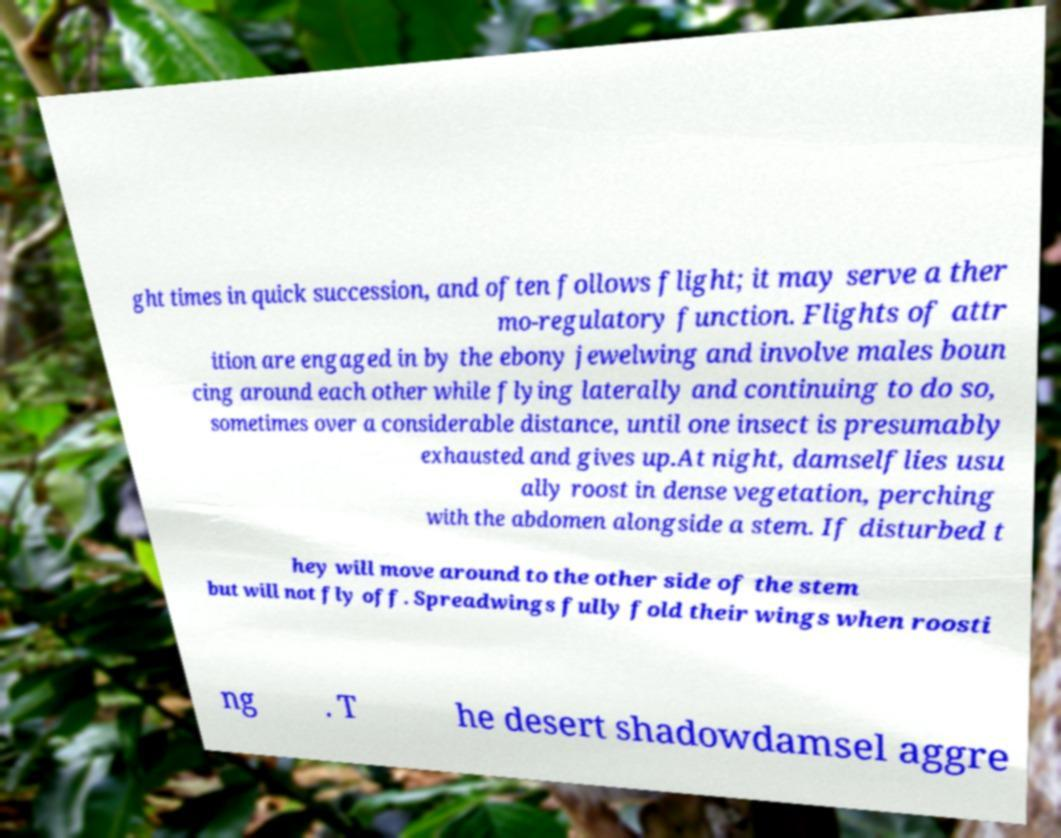Please identify and transcribe the text found in this image. ght times in quick succession, and often follows flight; it may serve a ther mo-regulatory function. Flights of attr ition are engaged in by the ebony jewelwing and involve males boun cing around each other while flying laterally and continuing to do so, sometimes over a considerable distance, until one insect is presumably exhausted and gives up.At night, damselflies usu ally roost in dense vegetation, perching with the abdomen alongside a stem. If disturbed t hey will move around to the other side of the stem but will not fly off. Spreadwings fully fold their wings when roosti ng . T he desert shadowdamsel aggre 